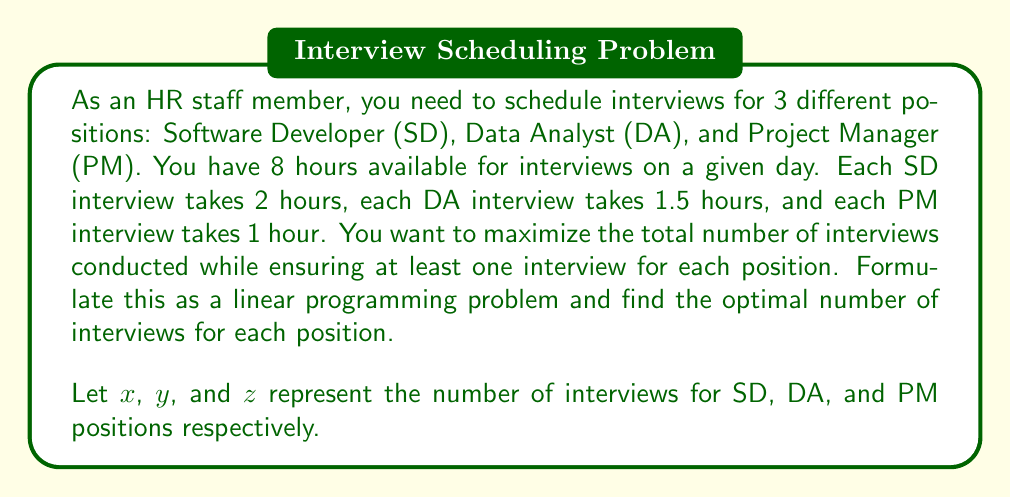Teach me how to tackle this problem. To solve this problem, we'll follow these steps:

1. Define the objective function
2. Identify the constraints
3. Set up the linear programming problem
4. Solve the problem using the simplex method or graphical method

Step 1: Define the objective function
We want to maximize the total number of interviews, so our objective function is:
$$\text{Maximize } f(x,y,z) = x + y + z$$

Step 2: Identify the constraints
a) Time constraint: Total interview time should not exceed 8 hours
$$2x + 1.5y + z \leq 8$$

b) Non-negativity constraints:
$$x \geq 0, y \geq 0, z \geq 0$$

c) At least one interview for each position:
$$x \geq 1, y \geq 1, z \geq 1$$

Step 3: Set up the linear programming problem
$$\begin{align*}
\text{Maximize } & f(x,y,z) = x + y + z \\
\text{Subject to: } & 2x + 1.5y + z \leq 8 \\
& x \geq 1 \\
& y \geq 1 \\
& z \geq 1 \\
& x, y, z \in \mathbb{Z}^+
\end{align*}$$

Step 4: Solve the problem
We can solve this problem using the simplex method or graphically. Given the integer constraint, we'll use a simple approach:

1. Start with the minimum required interviews: $x = 1, y = 1, z = 1$
2. This uses $2 + 1.5 + 1 = 4.5$ hours, leaving 3.5 hours
3. We can fit one more SD interview (2 hours) and one more DA interview (1.5 hours)

Therefore, the optimal solution is:
$$x = 2, y = 2, z = 1$$

This uses all 8 hours: $2(2) + 1.5(2) + 1(1) = 8$
Answer: The optimal number of interviews for each position is:
Software Developer (SD): 2
Data Analyst (DA): 2
Project Manager (PM): 1

Total number of interviews: 5 